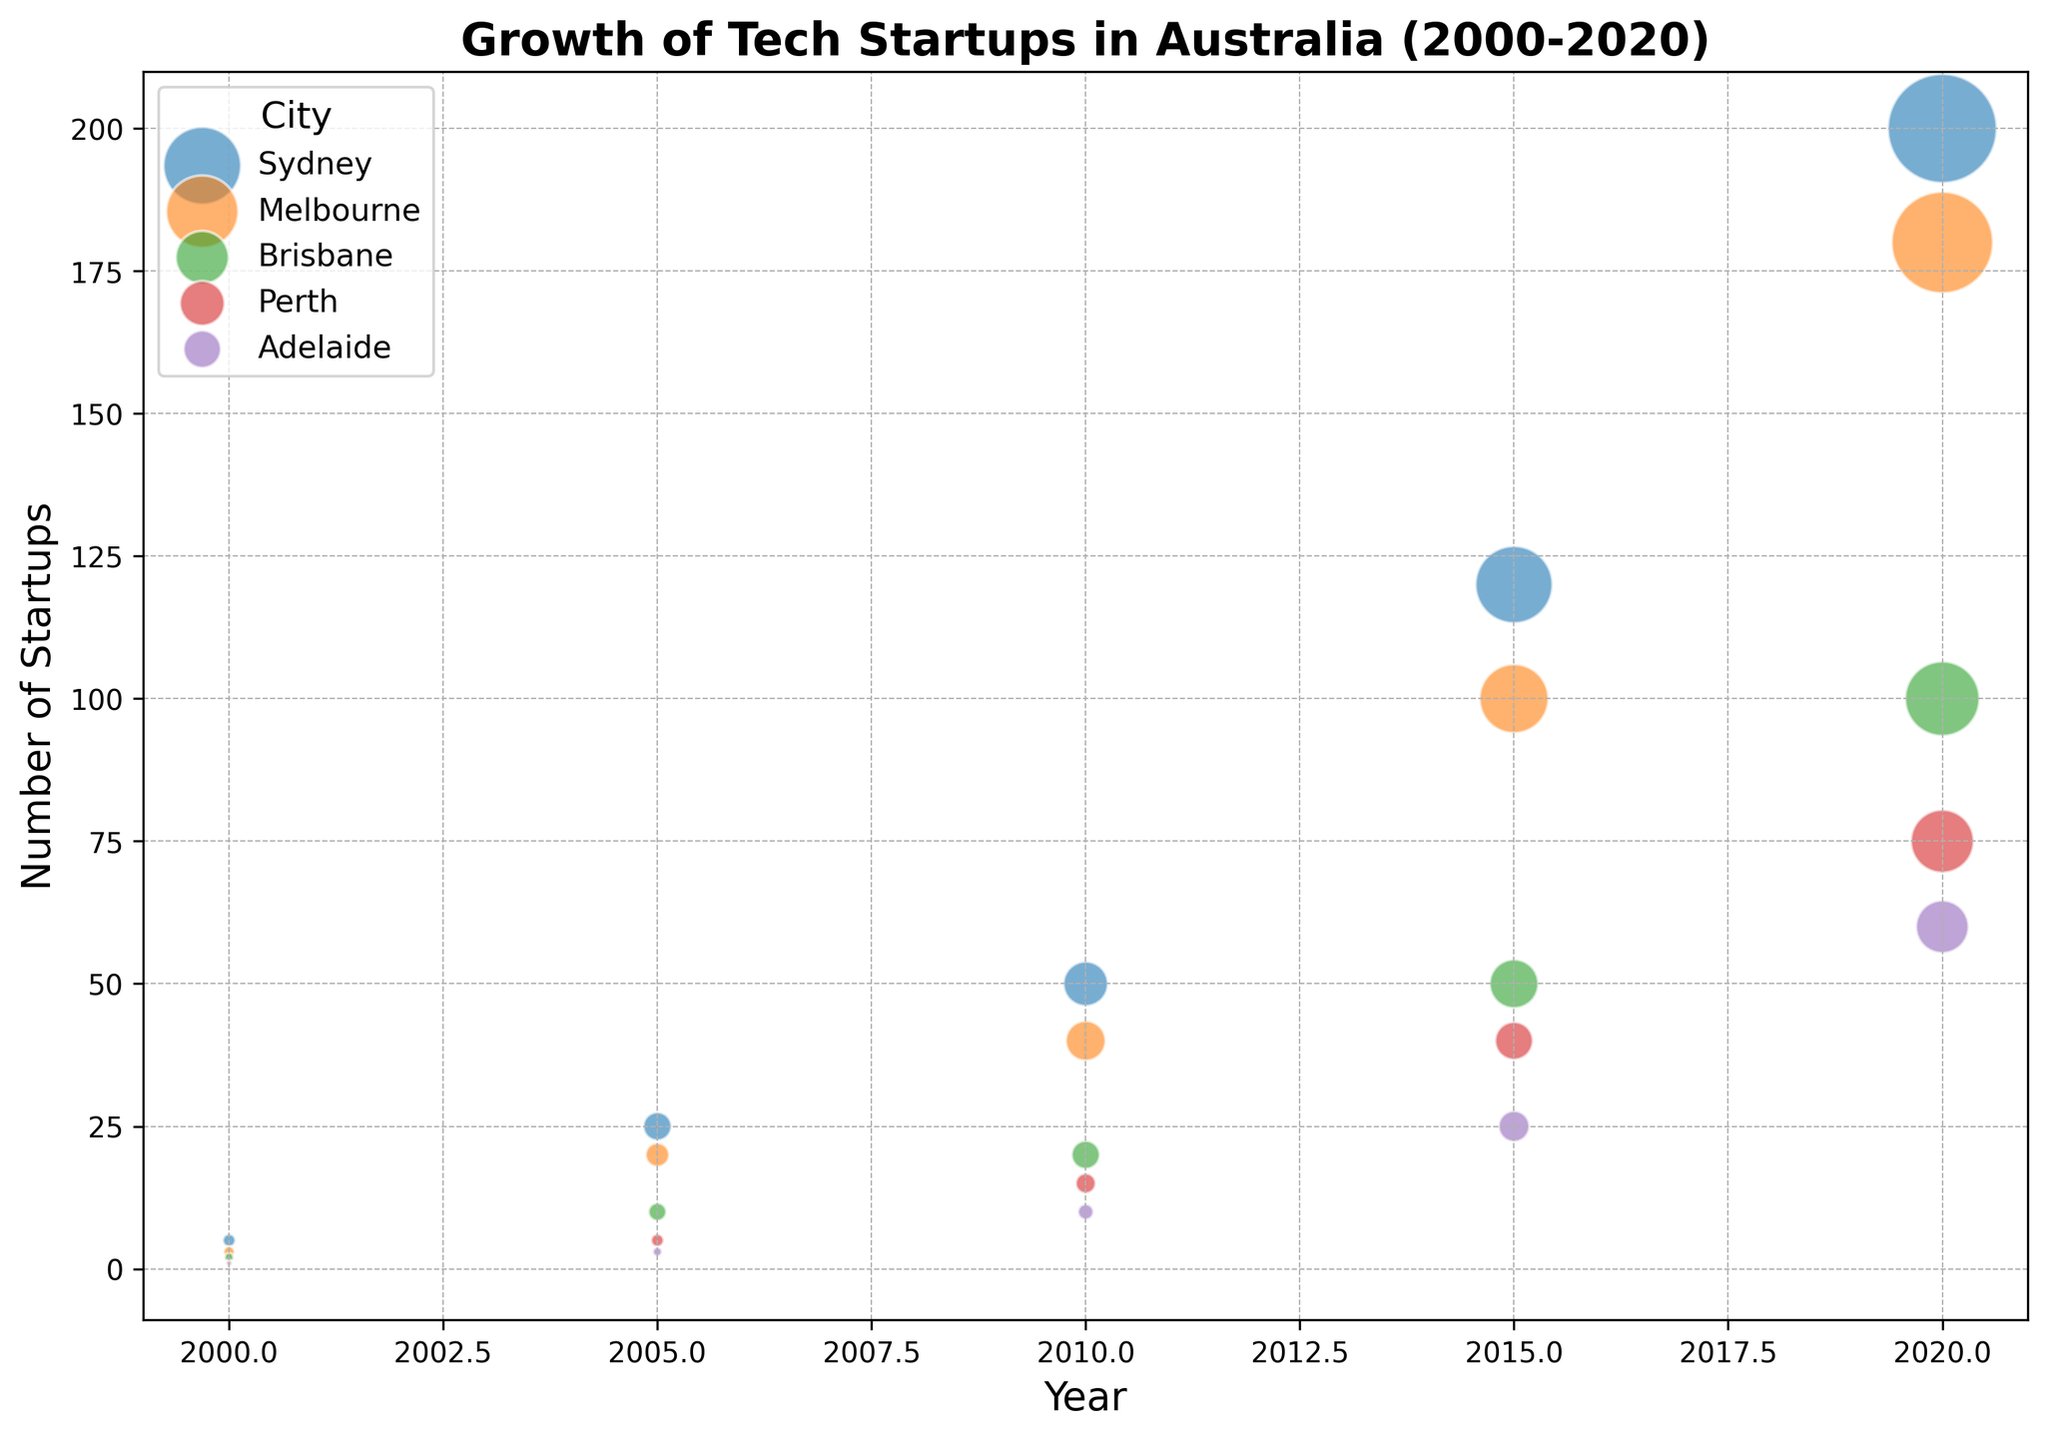How many more startups were there in Sydney in 2020 compared to 2000? In 2020, Sydney had 200 startups, and in 2000, it had 5 startups. The difference is 200 - 5.
Answer: 195 Which city had fewer startups, Adelaide or Perth in 2015? In 2015, Adelaide had 25 startups, while Perth had 40 startups. Therefore, Adelaide had fewer startups.
Answer: Adelaide Between which consecutive years did Brisbane see the largest increase in the number of startups? Comparing the increases: 2000 to 2005: 10 - 2 = 8, 2005 to 2010: 20 - 10 = 10, 2010 to 2015: 50 - 20 = 30, 2015 to 2020: 100 - 50 = 50. The largest increase was from 2015 to 2020.
Answer: 2015 to 2020 Which city had the highest funding amount in 2020? In 2020, Sydney had a funding amount of 150 million USD, Melbourne had 130 million USD, Brisbane had 70 million USD, Perth had 50 million USD, and Adelaide had 35 million USD. Sydney had the highest funding amount.
Answer: Sydney What’s the average funding amount (in millions) for tech startups in Melbourne from 2000 to 2020? Melbourne's funding amounts were: 1.5 (2000), 7 (2005), 20 (2010), 60 (2015), 130 (2020). The average is (1.5 + 7 + 20 + 60 + 130)/5.
Answer: 43.1 Which year did Sydney surpass 100 startups, and what was the funding amount that year? In 2015, Sydney had 120 startups, surpassing 100. The funding amount that year was 75 million USD.
Answer: 2015, 75 million USD How did the number of startups in Sydney change from 2005 to 2015? In 2005, Sydney had 25 startups. In 2015, Sydney had 120 startups. The change is 120 - 25.
Answer: 95 Which city had the smallest bubble size in 2000, and what was the funding amount? In 2000, Adelaide had the smallest bubble size with a funding amount of 0.2 million USD.
Answer: Adelaide, 0.2 million USD In which year did Melbourne have twice as many startups as Perth? In 2005, Melbourne had 20 startups, and Perth had 5 startups, which is twice as many.
Answer: 2005 